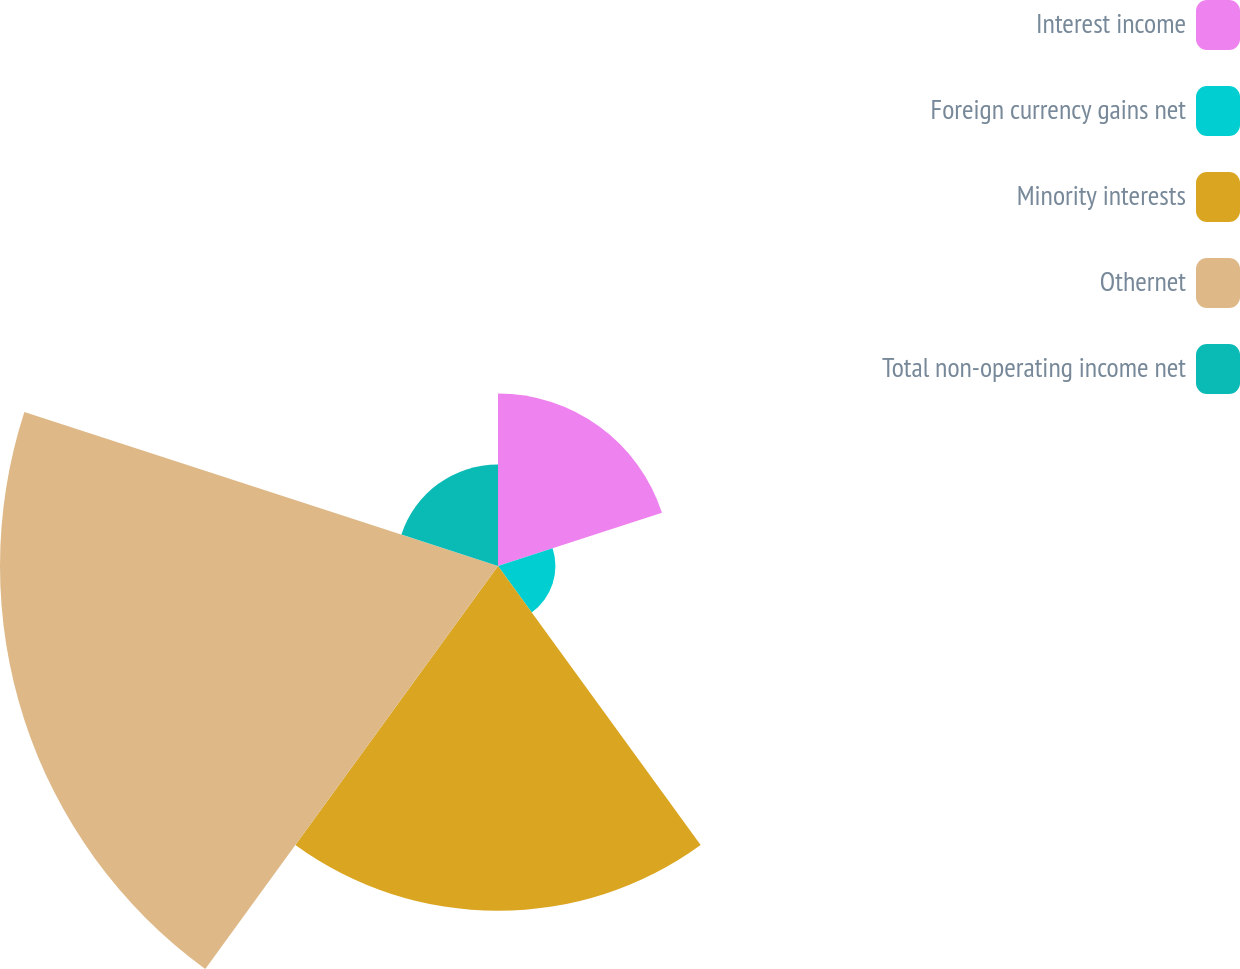Convert chart. <chart><loc_0><loc_0><loc_500><loc_500><pie_chart><fcel>Interest income<fcel>Foreign currency gains net<fcel>Minority interests<fcel>Othernet<fcel>Total non-operating income net<nl><fcel>14.68%<fcel>4.89%<fcel>29.36%<fcel>42.41%<fcel>8.65%<nl></chart> 